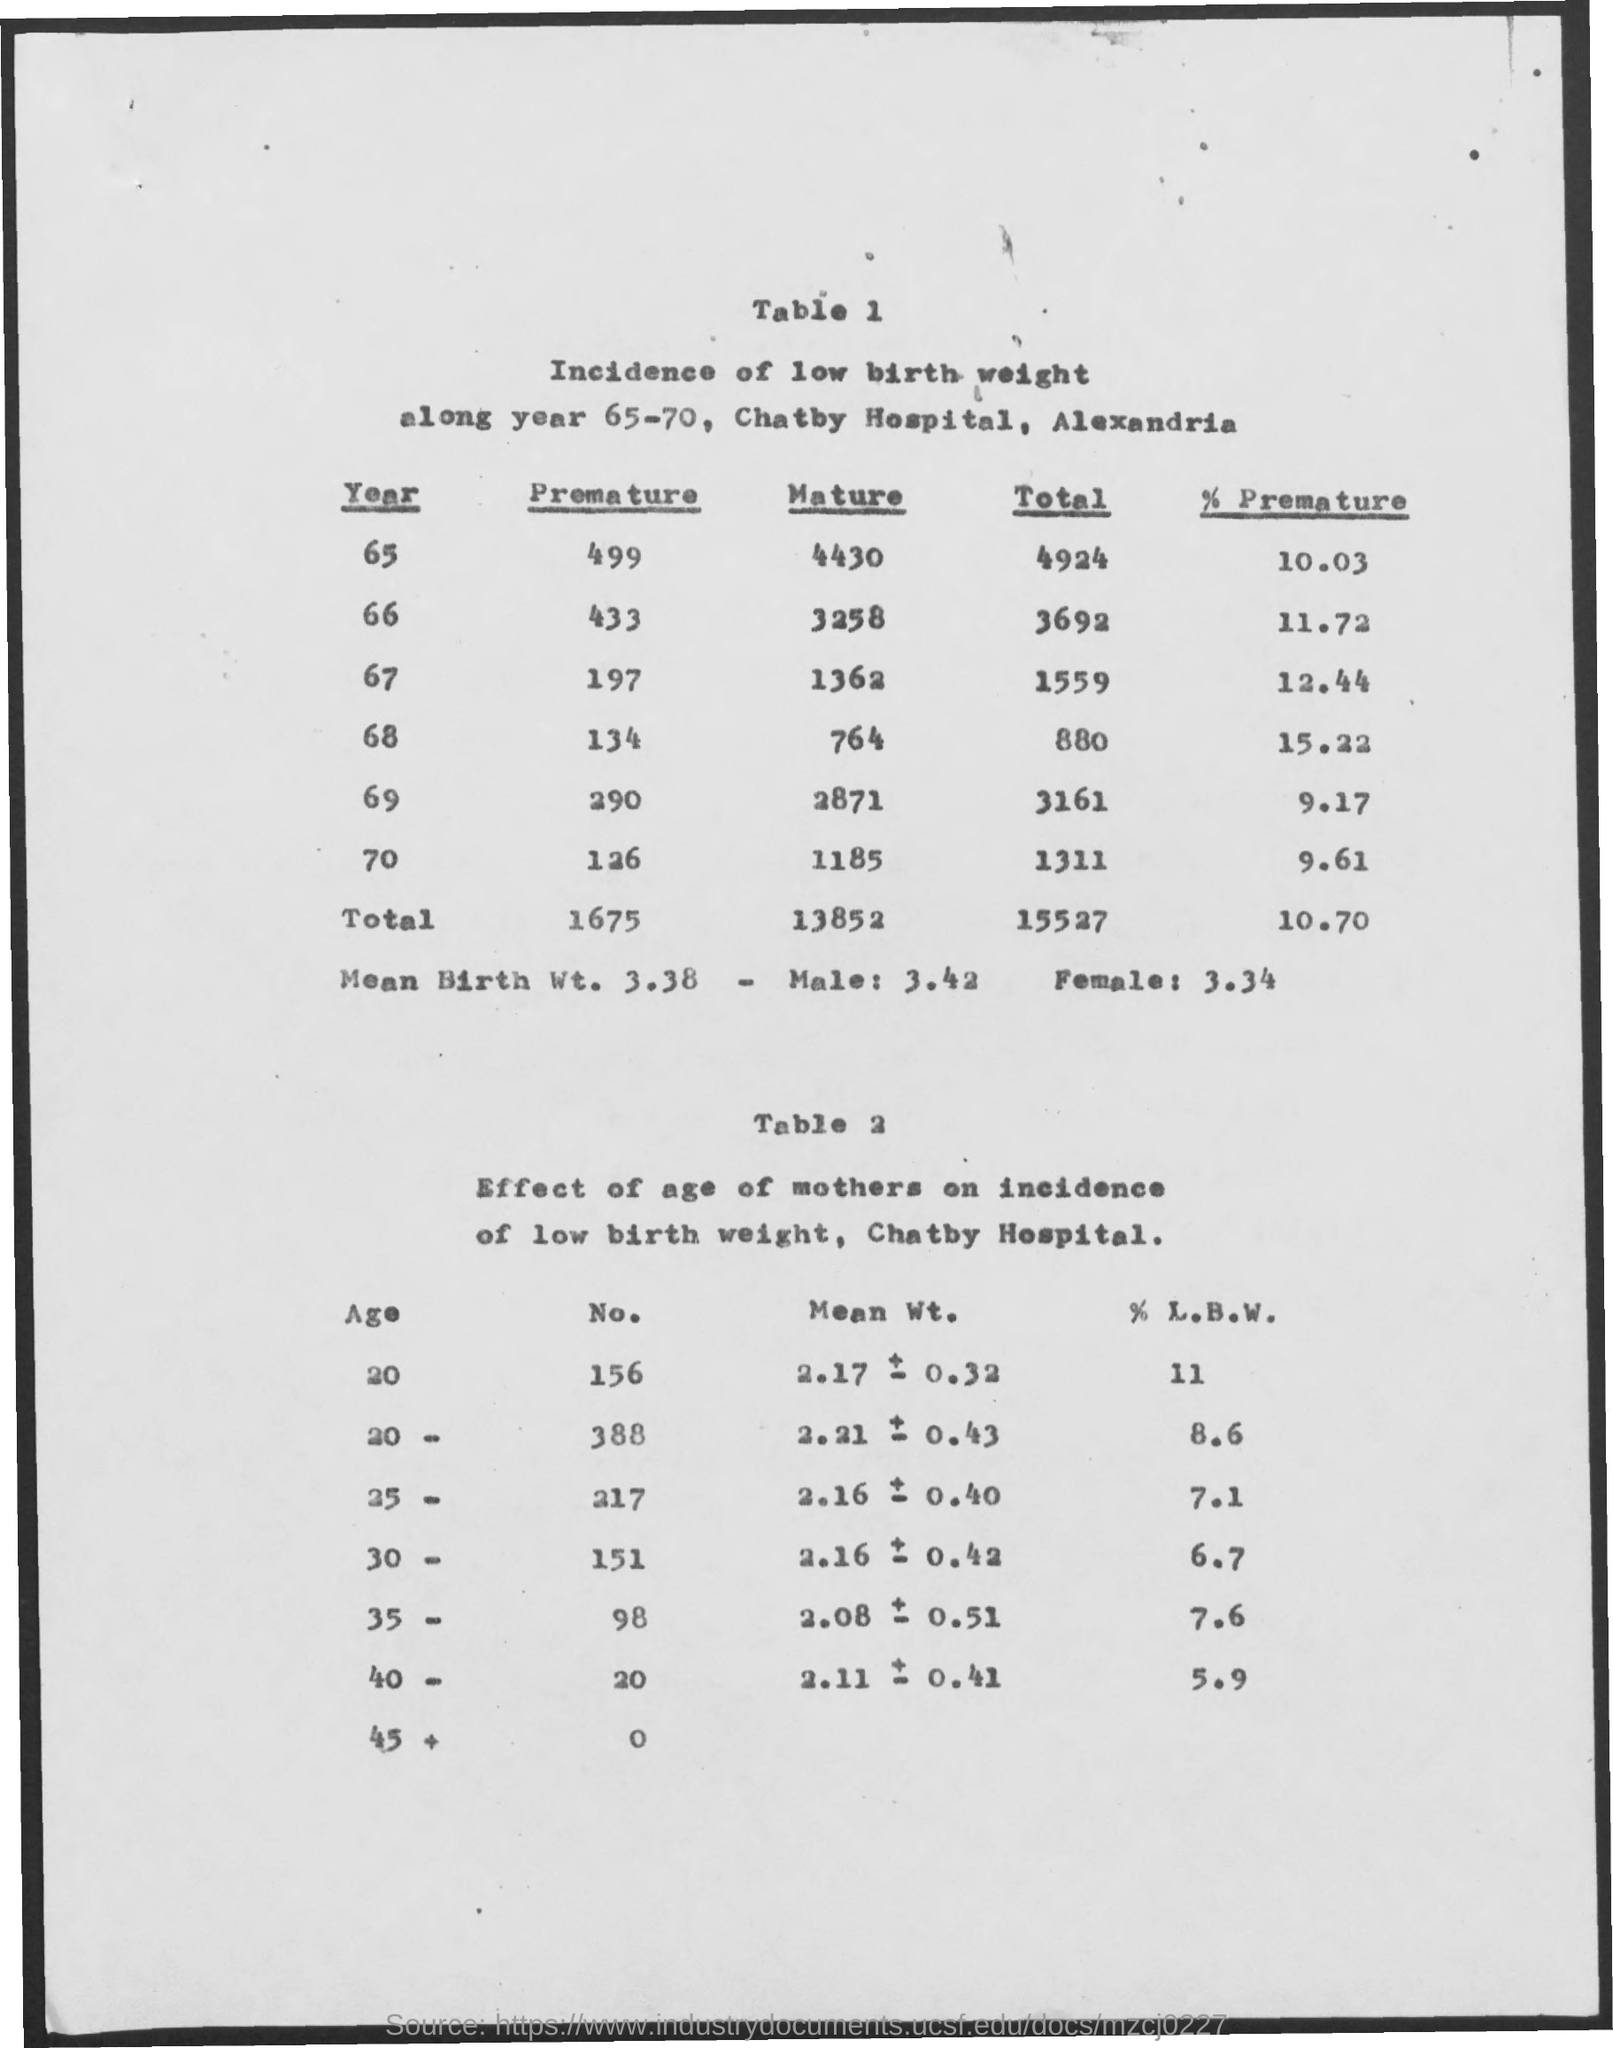Identify some key points in this picture. The total number of births in the year 65 was 4,924. The total number of mature births for the year 65-70 is 13852. The total number of premature births from the years 65-70 is 1675. Chatby Hospital is the name of the hospital. The low back pain (LBW) percentage for a person aged 20 for the number 156 is 11. 